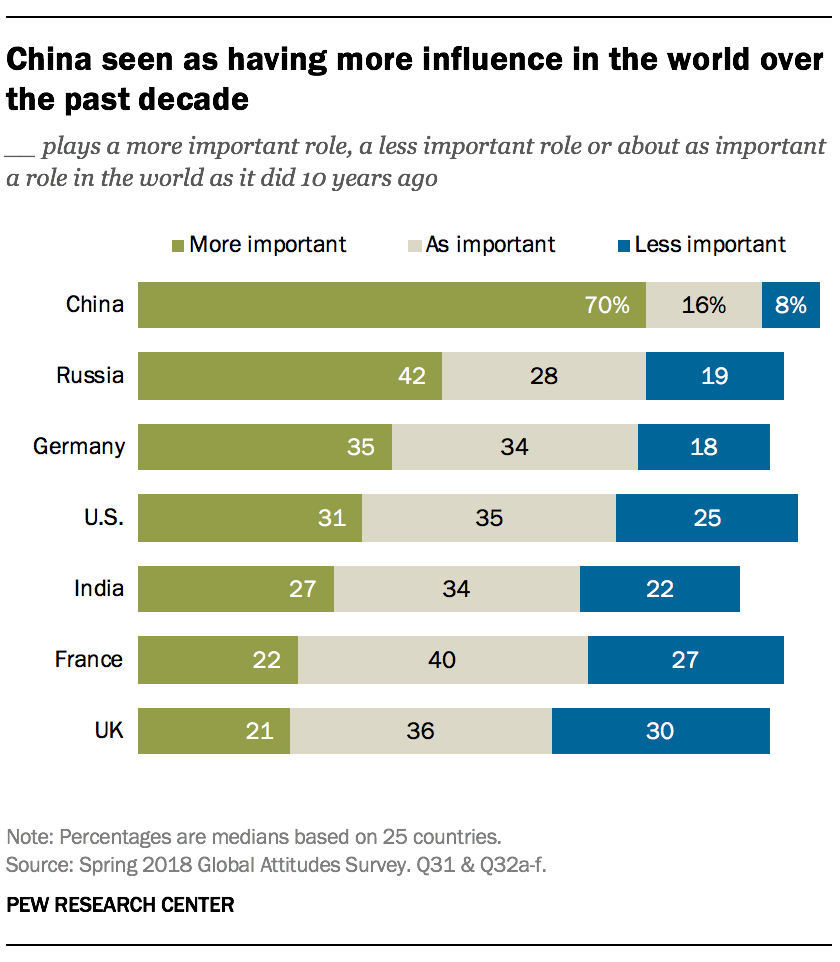Draw attention to some important aspects in this diagram. The value of two gray bars with the same value is 34. The ratio of India's green bar to the U.S. blue bar is 1.142361111... 